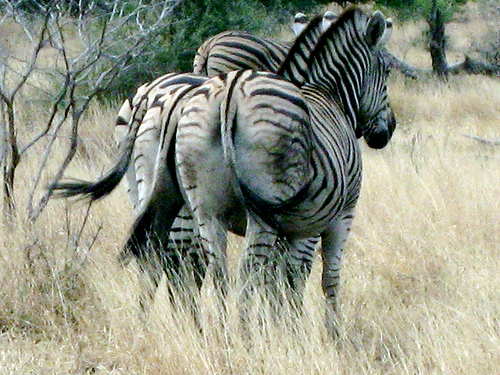Can you tell me what kind of habitat zebras live in? Zebras typically live in a variety of grasslands, savannas, and even mountainous habitats in Africa. The image shows a dry grassland, likely a savanna, which is a preferred environment for zebras as it provides ample grazing and allows them to spot predators at a distance. 